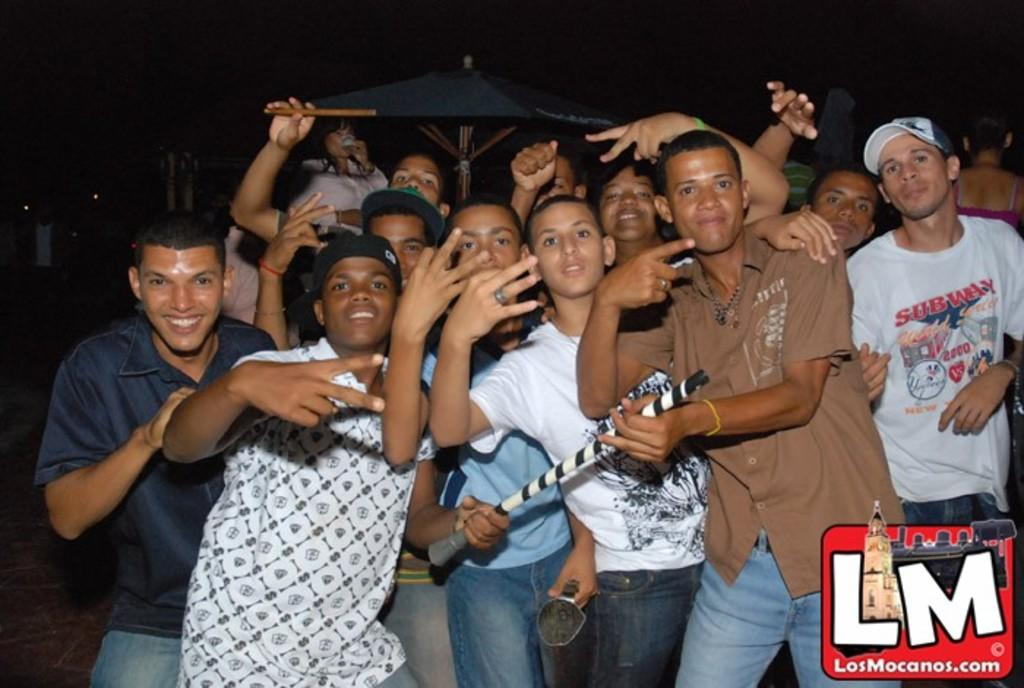How many people are in the image? There are many boys in the image. Can you describe any specific objects in the image? There is a black color umbrella in the back side of the image. What type of lift can be seen in the image? There is no lift present in the image. What is the composition of the air and earth in the image? The image does not provide information about the composition of air and earth. 